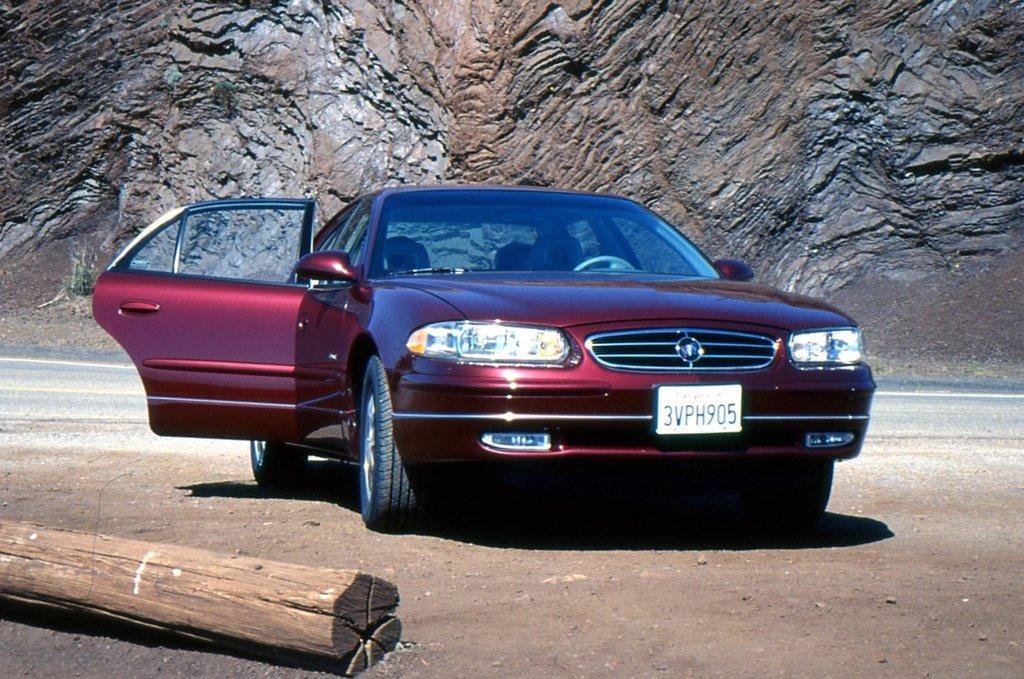Could you give a brief overview of what you see in this image? There is a car with number plate and the door is opened. On the left side there is a wooden log. In the back back there is a rock wall. Near to that there is a road. 